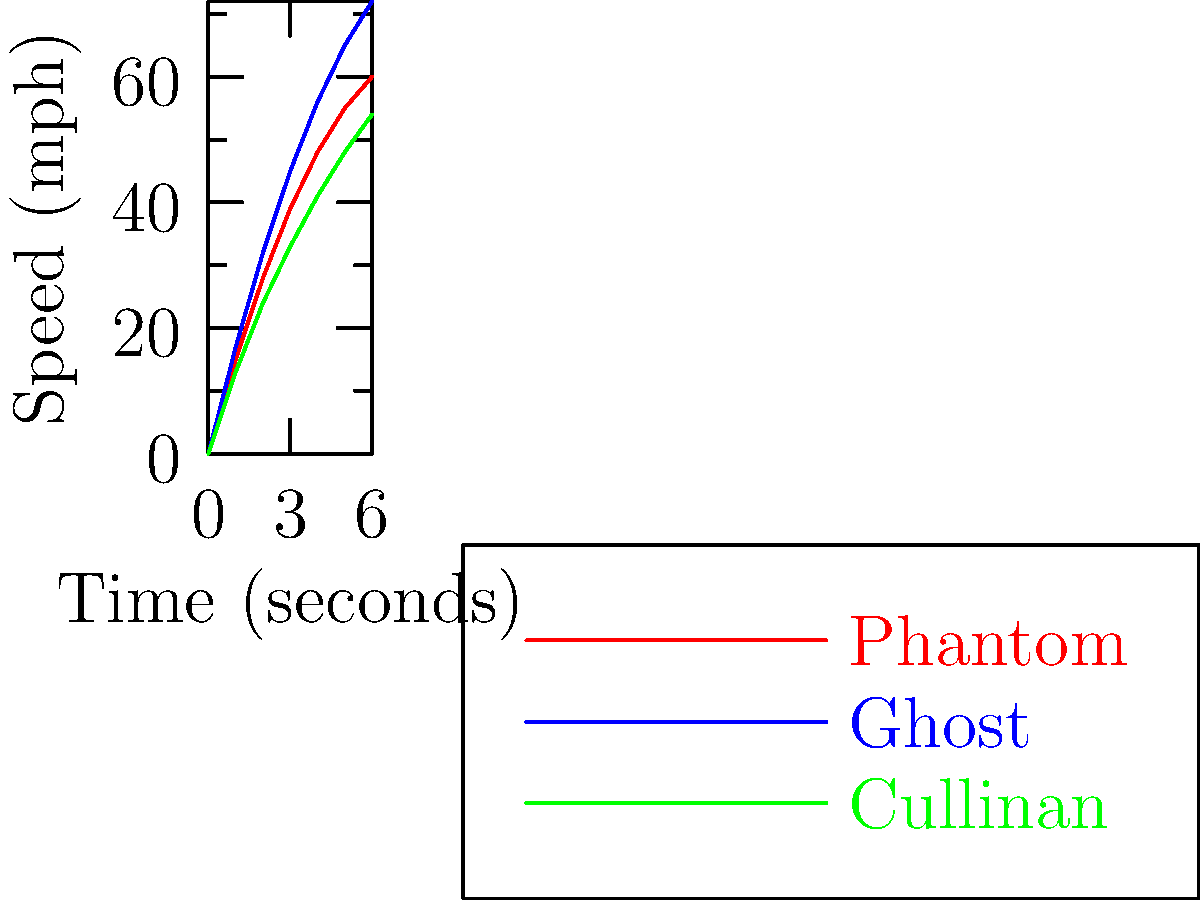Based on the acceleration curves shown in the graph, which Rolls-Royce model demonstrates the highest speed after 6 seconds, and what is the approximate difference in speed between this model and the slowest model at the 6-second mark? To answer this question, we need to follow these steps:

1. Identify the highest curve at the 6-second mark:
   - Phantom (red): about 60 mph
   - Ghost (blue): about 72 mph
   - Cullinan (green): about 54 mph

   The Ghost has the highest speed at 6 seconds.

2. Identify the lowest curve at the 6-second mark:
   The Cullinan has the lowest speed at 6 seconds, at about 54 mph.

3. Calculate the difference between the highest and lowest speeds:
   $72 \text{ mph} - 54 \text{ mph} = 18 \text{ mph}$

Therefore, the Ghost demonstrates the highest speed after 6 seconds, and the approximate difference in speed between the Ghost and the Cullinan (the slowest model) at the 6-second mark is 18 mph.
Answer: Ghost; 18 mph 